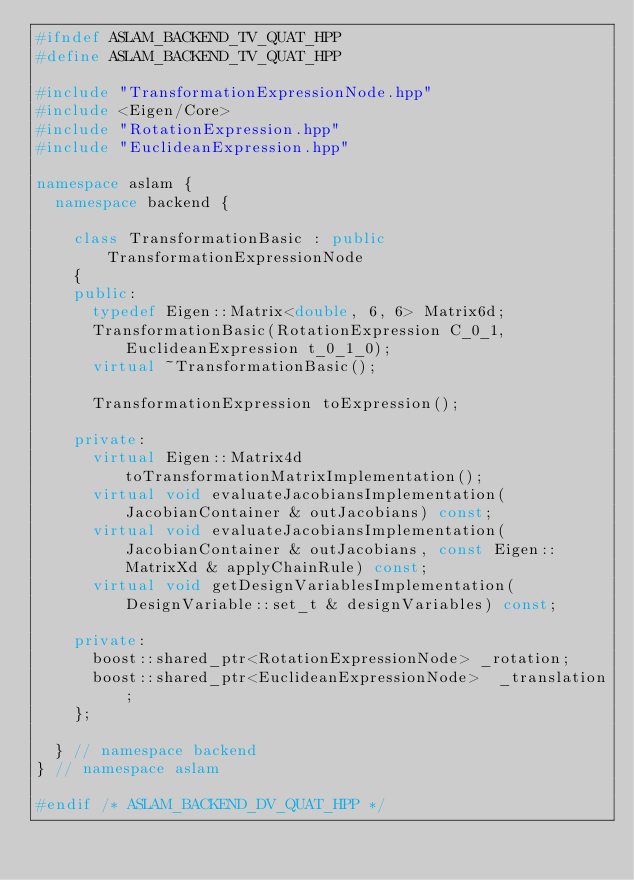Convert code to text. <code><loc_0><loc_0><loc_500><loc_500><_C++_>#ifndef ASLAM_BACKEND_TV_QUAT_HPP
#define ASLAM_BACKEND_TV_QUAT_HPP

#include "TransformationExpressionNode.hpp"
#include <Eigen/Core>
#include "RotationExpression.hpp"
#include "EuclideanExpression.hpp"

namespace aslam {
  namespace backend {
    
    class TransformationBasic : public TransformationExpressionNode
    {
    public:
      typedef Eigen::Matrix<double, 6, 6> Matrix6d;
      TransformationBasic(RotationExpression C_0_1, EuclideanExpression t_0_1_0);
      virtual ~TransformationBasic();

      TransformationExpression toExpression();

    private:
      virtual Eigen::Matrix4d toTransformationMatrixImplementation();
      virtual void evaluateJacobiansImplementation(JacobianContainer & outJacobians) const;
      virtual void evaluateJacobiansImplementation(JacobianContainer & outJacobians, const Eigen::MatrixXd & applyChainRule) const;
      virtual void getDesignVariablesImplementation(DesignVariable::set_t & designVariables) const;
      
    private:
      boost::shared_ptr<RotationExpressionNode> _rotation;
      boost::shared_ptr<EuclideanExpressionNode>  _translation;
    };

  } // namespace backend
} // namespace aslam

#endif /* ASLAM_BACKEND_DV_QUAT_HPP */
</code> 